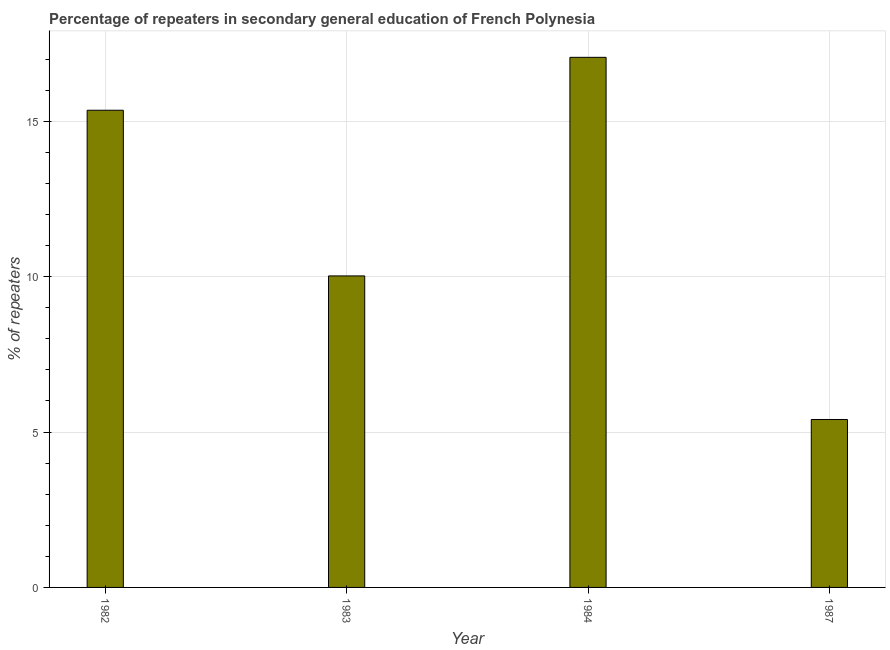Does the graph contain any zero values?
Offer a terse response. No. Does the graph contain grids?
Offer a very short reply. Yes. What is the title of the graph?
Give a very brief answer. Percentage of repeaters in secondary general education of French Polynesia. What is the label or title of the X-axis?
Provide a short and direct response. Year. What is the label or title of the Y-axis?
Give a very brief answer. % of repeaters. What is the percentage of repeaters in 1984?
Offer a very short reply. 17.06. Across all years, what is the maximum percentage of repeaters?
Provide a short and direct response. 17.06. Across all years, what is the minimum percentage of repeaters?
Make the answer very short. 5.41. In which year was the percentage of repeaters minimum?
Make the answer very short. 1987. What is the sum of the percentage of repeaters?
Ensure brevity in your answer.  47.85. What is the difference between the percentage of repeaters in 1982 and 1987?
Give a very brief answer. 9.95. What is the average percentage of repeaters per year?
Give a very brief answer. 11.96. What is the median percentage of repeaters?
Offer a very short reply. 12.69. In how many years, is the percentage of repeaters greater than 7 %?
Give a very brief answer. 3. Do a majority of the years between 1987 and 1983 (inclusive) have percentage of repeaters greater than 2 %?
Offer a terse response. Yes. What is the ratio of the percentage of repeaters in 1982 to that in 1983?
Provide a succinct answer. 1.53. Is the percentage of repeaters in 1983 less than that in 1987?
Provide a short and direct response. No. Is the difference between the percentage of repeaters in 1982 and 1983 greater than the difference between any two years?
Make the answer very short. No. What is the difference between the highest and the second highest percentage of repeaters?
Offer a terse response. 1.7. Is the sum of the percentage of repeaters in 1982 and 1984 greater than the maximum percentage of repeaters across all years?
Give a very brief answer. Yes. What is the difference between the highest and the lowest percentage of repeaters?
Make the answer very short. 11.66. How many years are there in the graph?
Ensure brevity in your answer.  4. What is the difference between two consecutive major ticks on the Y-axis?
Your answer should be compact. 5. What is the % of repeaters of 1982?
Your answer should be very brief. 15.36. What is the % of repeaters of 1983?
Your answer should be very brief. 10.03. What is the % of repeaters in 1984?
Your response must be concise. 17.06. What is the % of repeaters of 1987?
Your answer should be compact. 5.41. What is the difference between the % of repeaters in 1982 and 1983?
Provide a succinct answer. 5.33. What is the difference between the % of repeaters in 1982 and 1984?
Keep it short and to the point. -1.7. What is the difference between the % of repeaters in 1982 and 1987?
Provide a short and direct response. 9.95. What is the difference between the % of repeaters in 1983 and 1984?
Provide a short and direct response. -7.03. What is the difference between the % of repeaters in 1983 and 1987?
Your response must be concise. 4.62. What is the difference between the % of repeaters in 1984 and 1987?
Provide a succinct answer. 11.66. What is the ratio of the % of repeaters in 1982 to that in 1983?
Give a very brief answer. 1.53. What is the ratio of the % of repeaters in 1982 to that in 1987?
Provide a succinct answer. 2.84. What is the ratio of the % of repeaters in 1983 to that in 1984?
Give a very brief answer. 0.59. What is the ratio of the % of repeaters in 1983 to that in 1987?
Offer a terse response. 1.85. What is the ratio of the % of repeaters in 1984 to that in 1987?
Your response must be concise. 3.16. 